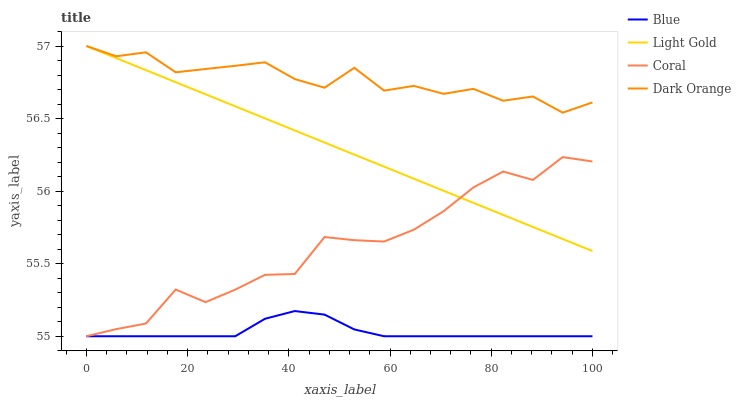Does Blue have the minimum area under the curve?
Answer yes or no. Yes. Does Dark Orange have the maximum area under the curve?
Answer yes or no. Yes. Does Coral have the minimum area under the curve?
Answer yes or no. No. Does Coral have the maximum area under the curve?
Answer yes or no. No. Is Light Gold the smoothest?
Answer yes or no. Yes. Is Coral the roughest?
Answer yes or no. Yes. Is Dark Orange the smoothest?
Answer yes or no. No. Is Dark Orange the roughest?
Answer yes or no. No. Does Dark Orange have the lowest value?
Answer yes or no. No. Does Light Gold have the highest value?
Answer yes or no. Yes. Does Coral have the highest value?
Answer yes or no. No. Is Blue less than Dark Orange?
Answer yes or no. Yes. Is Light Gold greater than Blue?
Answer yes or no. Yes. Does Dark Orange intersect Light Gold?
Answer yes or no. Yes. Is Dark Orange less than Light Gold?
Answer yes or no. No. Is Dark Orange greater than Light Gold?
Answer yes or no. No. Does Blue intersect Dark Orange?
Answer yes or no. No. 